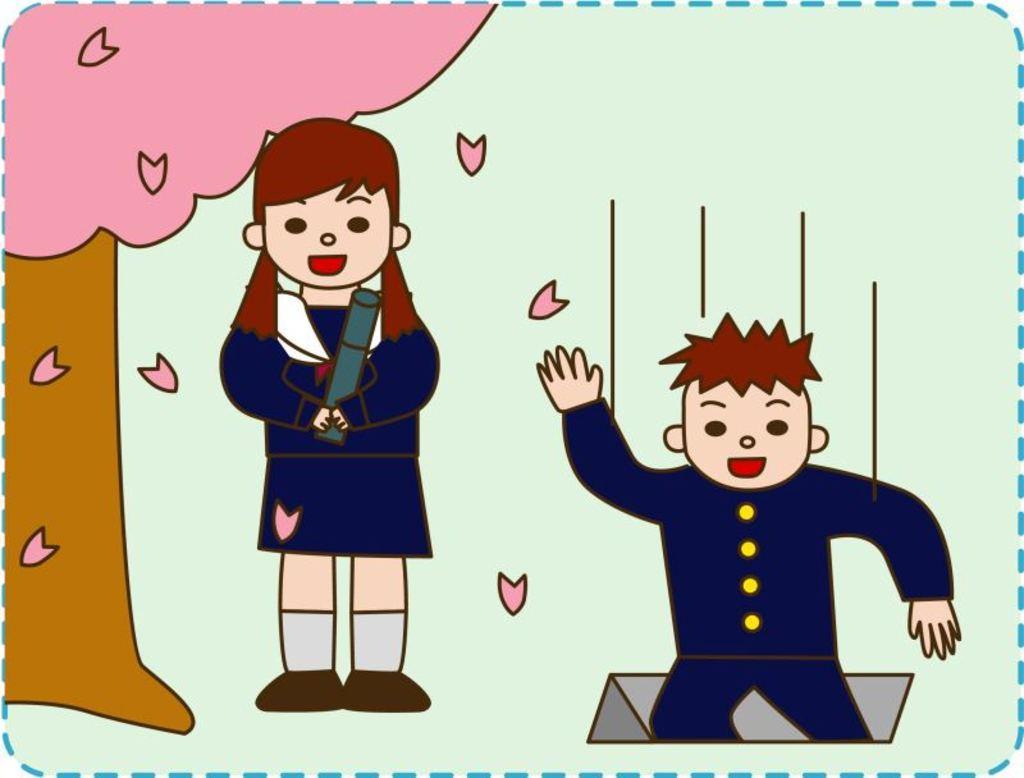Can you describe this image briefly? This image consists of an art of a girl, a boy and a tree. In this image the background is green in color. 